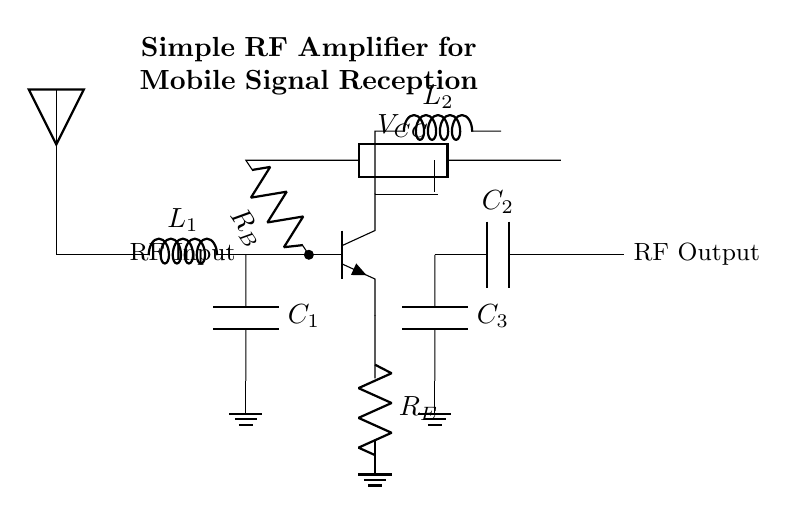What is the type of the amplifier used in this circuit? The amplifier is a bipolar junction transistor, specifically an NPN type, as indicated by the npn symbol in the circuit.
Answer: NPN What is the purpose of component C1? Component C1, shown as a capacitor, is part of the matching network that helps tune the input signal frequency for optimal amplification.
Answer: Matching How many resistors are present in the circuit? There are two resistors present: one for biasing the transistor (R_B) and one as an emitter resistor (R_E).
Answer: Two What is the output of this circuit labeled as? The output of the circuit is labeled as RF Output, which refers to the amplified radio frequency signal that can be used further in communication.
Answer: RF Output What does the component L2 do in this circuit? Component L2 is an inductor that is used for output matching, helping to tune the output frequency and improve efficiency of the RF amplifier by reducing unwanted signals.
Answer: Output matching What is the role of the component R_E? R_E, the emitter resistor, helps to stabilize the operating point of the transistor by providing negative feedback, which is important for consistent performance over varying signal conditions.
Answer: Stabilization 